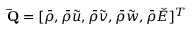<formula> <loc_0><loc_0><loc_500><loc_500>\bar { Q } = [ \bar { \rho } , \bar { \rho } \tilde { u } , \bar { \rho } \tilde { v } , \bar { \rho } \tilde { w } , \bar { \rho } \check { E } ] ^ { T }</formula> 